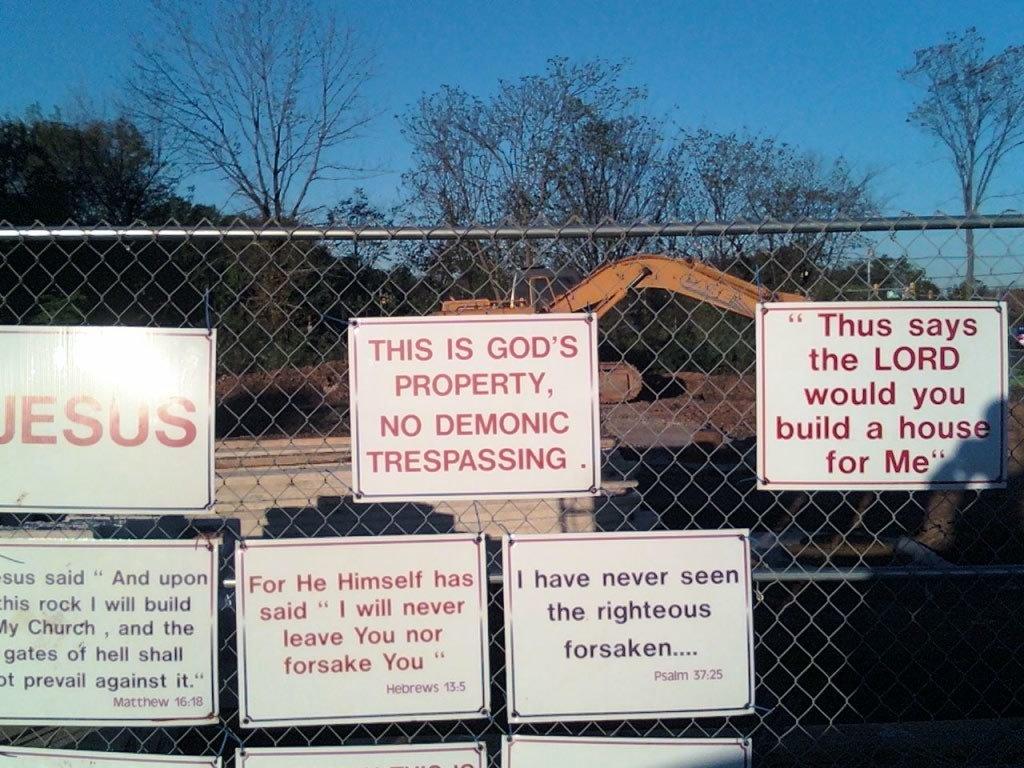Who does the property belong to?
Provide a succinct answer. God. What is written on the poster on the far right?
Your answer should be compact. Thus says the lord would you build a house for me. 